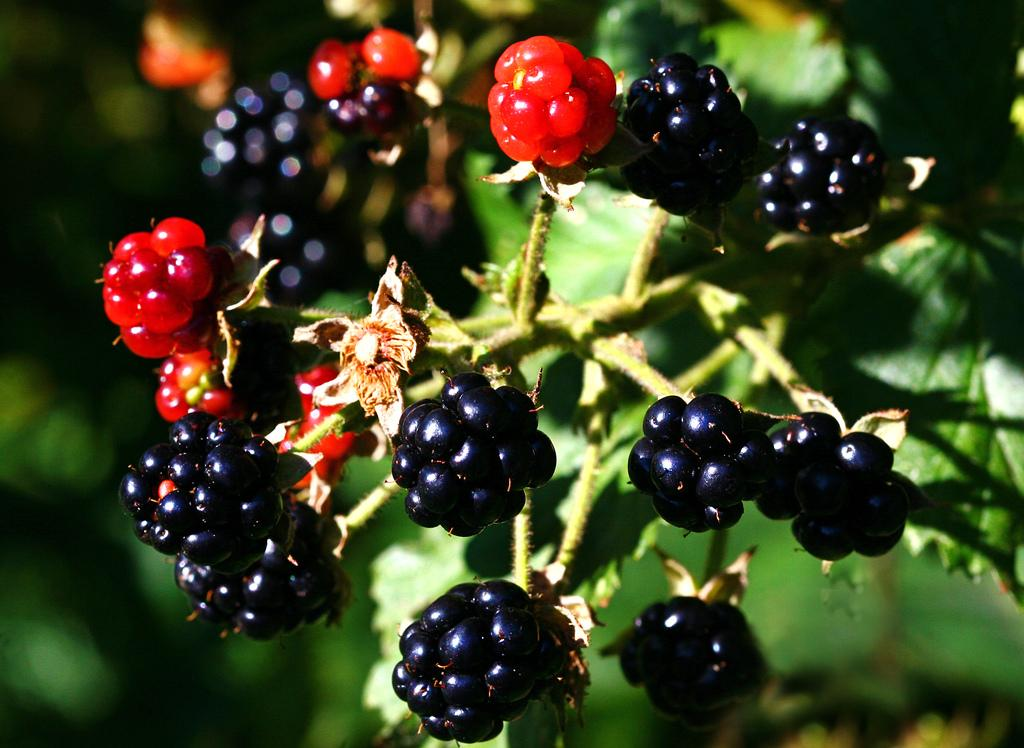What is the main subject of the image? The main subject of the image is a tree. Where is the tree located in the image? The tree is in the center of the image. What is special about the tree in the image? The tree has fruits. What colors are the fruits on the tree? The fruits are in red and black colors. Can you see a locket hanging from the tree in the image? No, there is no locket present in the image. How does the seashore affect the growth of the tree in the image? The image does not depict a seashore, so it cannot affect the growth of the tree in the image. 